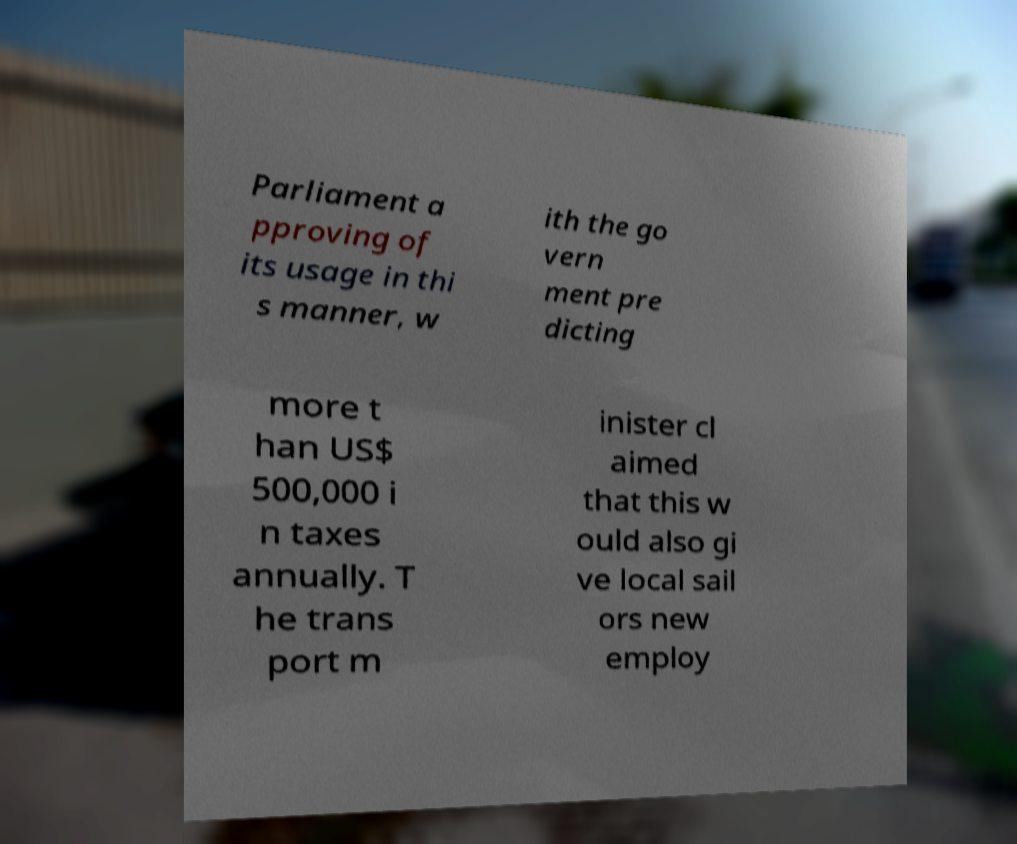Please read and relay the text visible in this image. What does it say? Parliament a pproving of its usage in thi s manner, w ith the go vern ment pre dicting more t han US$ 500,000 i n taxes annually. T he trans port m inister cl aimed that this w ould also gi ve local sail ors new employ 